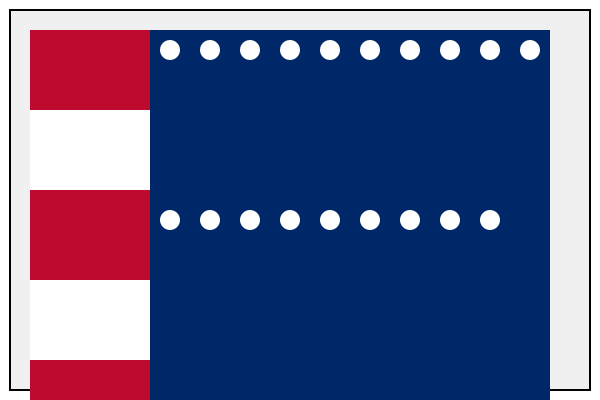As a patriotic American, which of the following flag configurations accurately represents the current United States flag? Choose between option A and B. To identify the correct US flag configuration, we need to consider the following key elements:

1. Stripes: Both options show the correct 13 stripes (7 red and 6 white), alternating with red at the top and bottom.

2. Blue field (canton): Both options have the blue field in the correct position, occupying the upper left corner.

3. Stars: This is where the difference lies:
   - Option A shows 10 stars in a single row
   - Option B shows 9 stars in a single row

4. Historical context: The current US flag, also known as the "Stars and Stripes," has had 50 stars since 1960, representing the 50 states of the Union.

5. Star arrangement: The official flag has 9 rows of stars alternating between 6 and 5 stars per row, totaling 50 stars.

While neither option shows the full 50-star configuration, option B with 9 stars is closer to the correct representation of a row on the actual flag. Option A with 10 stars does not match any row on the current US flag.
Answer: B 